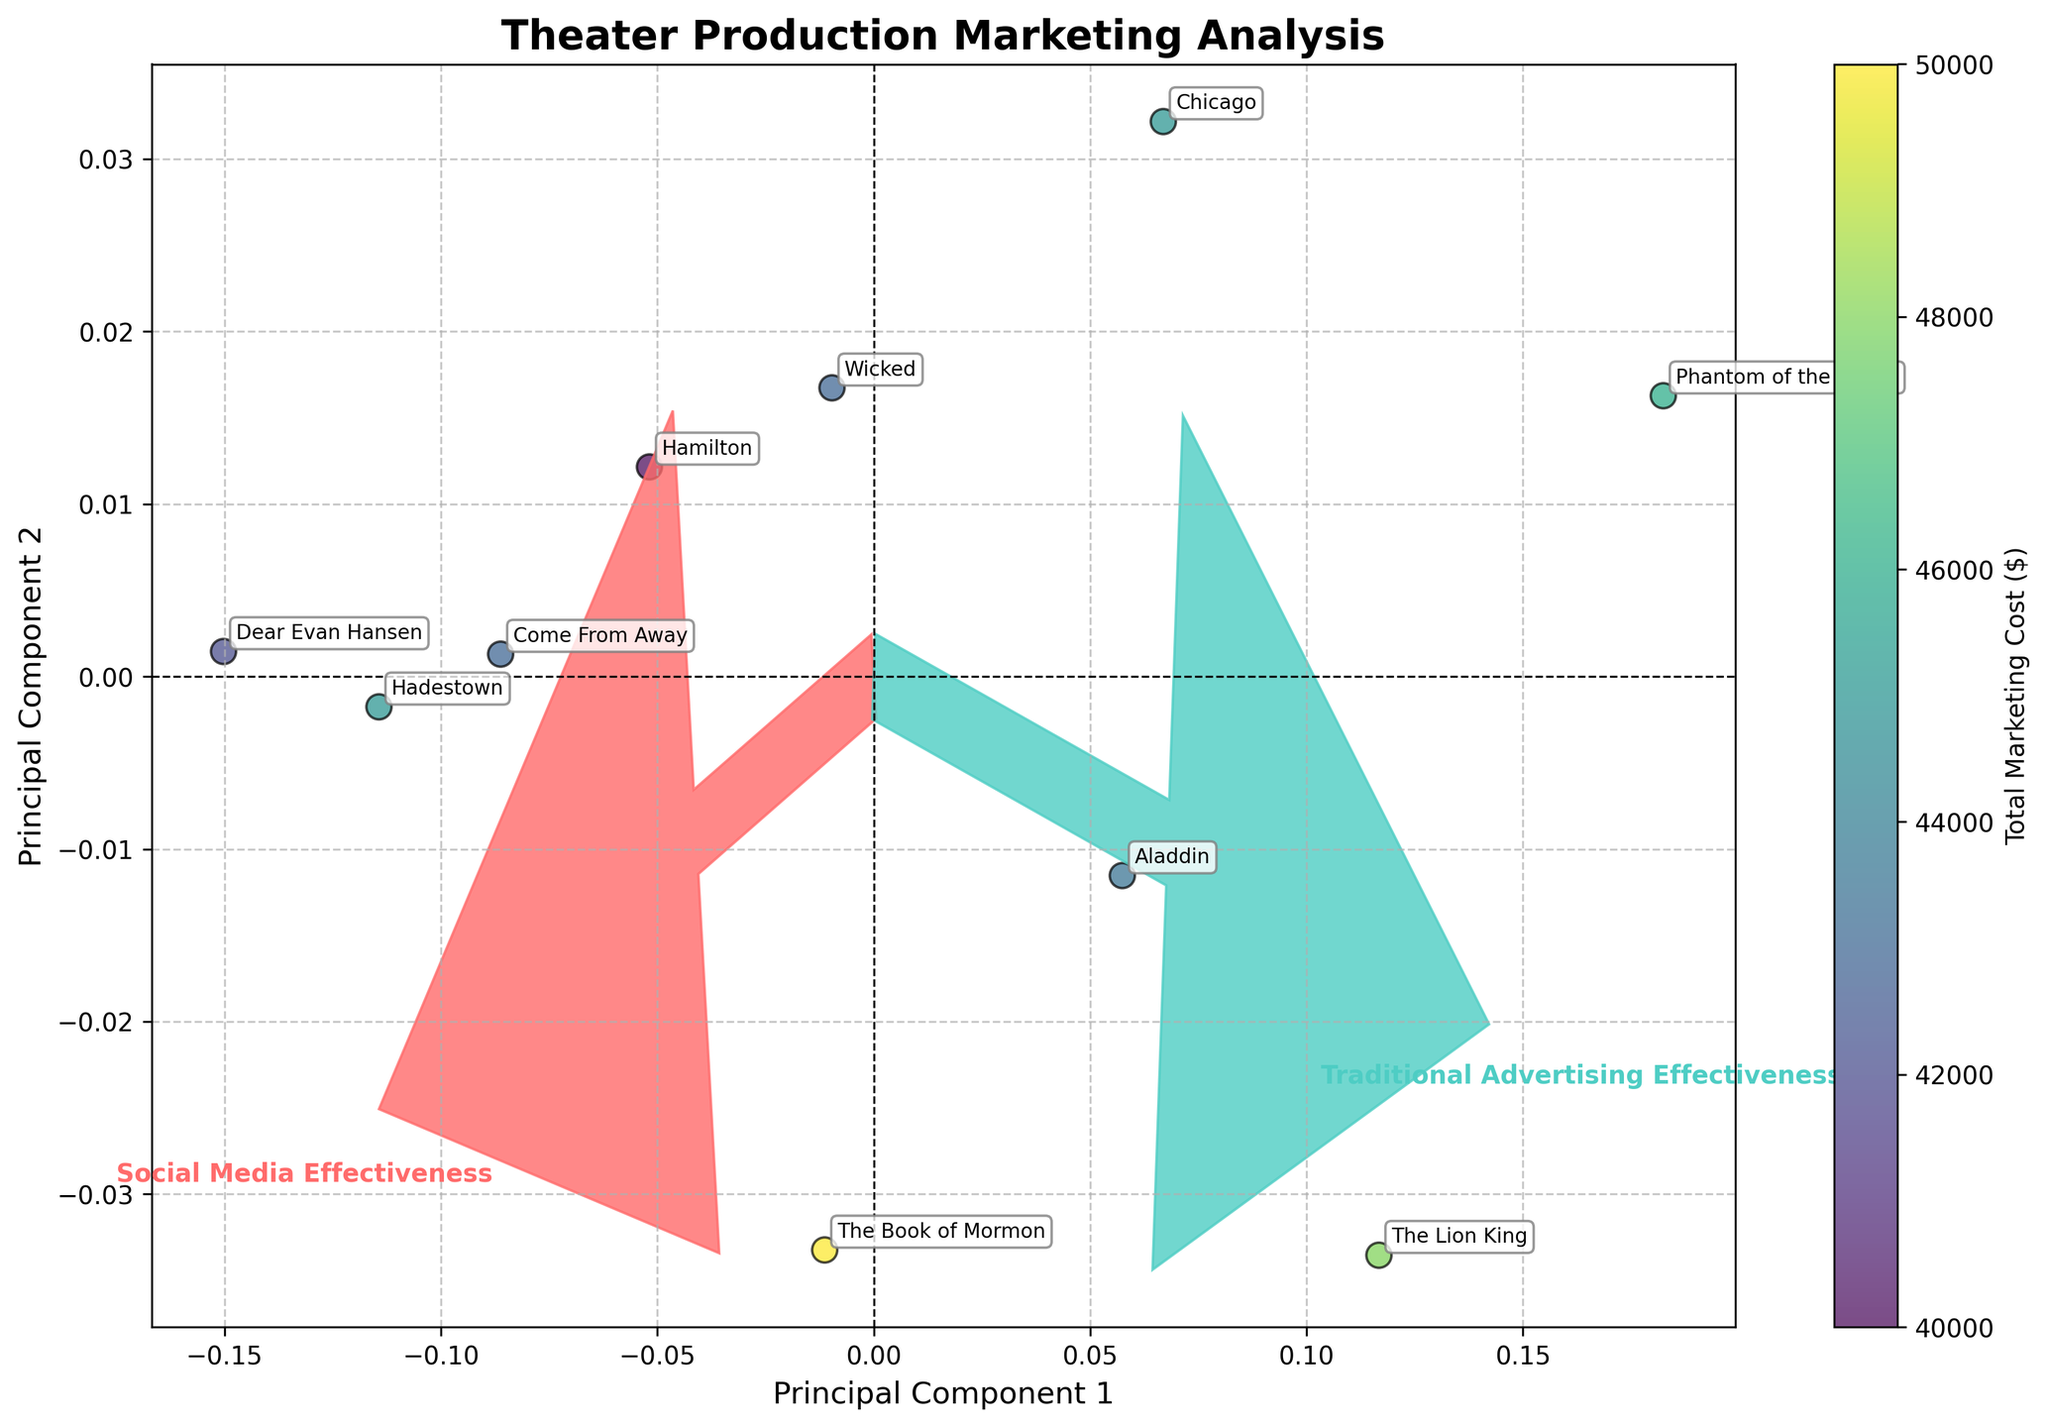What's the title of the figure? The title is located at the top of the figure. It summarizes the main topic of the visual representation. You can easily read it to identify the subject of the plot.
Answer: Theater Production Marketing Analysis How many theater productions are represented in the biplot? The plot has an annotated label for each data point representing a theater production. By counting all these distinct labels, you will get the total number of productions.
Answer: 10 Which theater production is highlighted as having the highest overall marketing cost? The color intensity of the scatter points represents the total marketing cost, with darker colors indicating higher costs. Identifying the most intense color and its corresponding label will reveal the production with the highest cost.
Answer: Hadestown Among Hamilton and Wicked, which theater production shows higher effectiveness in traditional advertising? Locate the points for Hamilton and Wicked, and compare their positions along the direction of the Traditional Advertising Effectiveness vector. The point farther along this vector corresponds to the higher effectiveness.
Answer: The Lion King Which variable vector is aligned more closely with Principal Component 2? Look at the two vectors representing the variables in the biplot. The vector more aligned with the y-axis (Principal Component 2) suggests which variable it corresponds more with.
Answer: Traditional Advertising Effectiveness What are the principal components used in this biplot? The x-axis and y-axis labels state the principal components. These reflect the new axes after applying PCA to the original variables, summarizing the variance in data.
Answer: Principal Component 1 and Principal Component 2 Which theater production shows a similar effectiveness in both marketing channels? Points closer to the line y = x diagonal represent similar values in both axes (effectiveness measures). Locate the point nearest to this line.
Answer: Aladdin How does the traditional advertising effectiveness of 'Dear Evan Hansen' compare to 'Phantom of the Opera'? Identify both points' positions in the biplot and compare their projections on the Traditional Advertising Effectiveness axis (considering the corresponding vector's direction).
Answer: Dear Evan Hansen is lower What does a longer length of the variable vectors signify in the context of this biplot? Longer vectors in a biplot indicate that the variable has high variance and a stronger influence on the principal components. The significance is in how much each variable contributes to the data's spread.
Answer: Higher influence of variable Which theater production is closest to the origin, and what does that imply about its marketing effectiveness? The production closest to the origin (0,0) would have the least projections on both principal components, signifying average or neutral effectiveness in both marketing channels.
Answer: Hamilton 